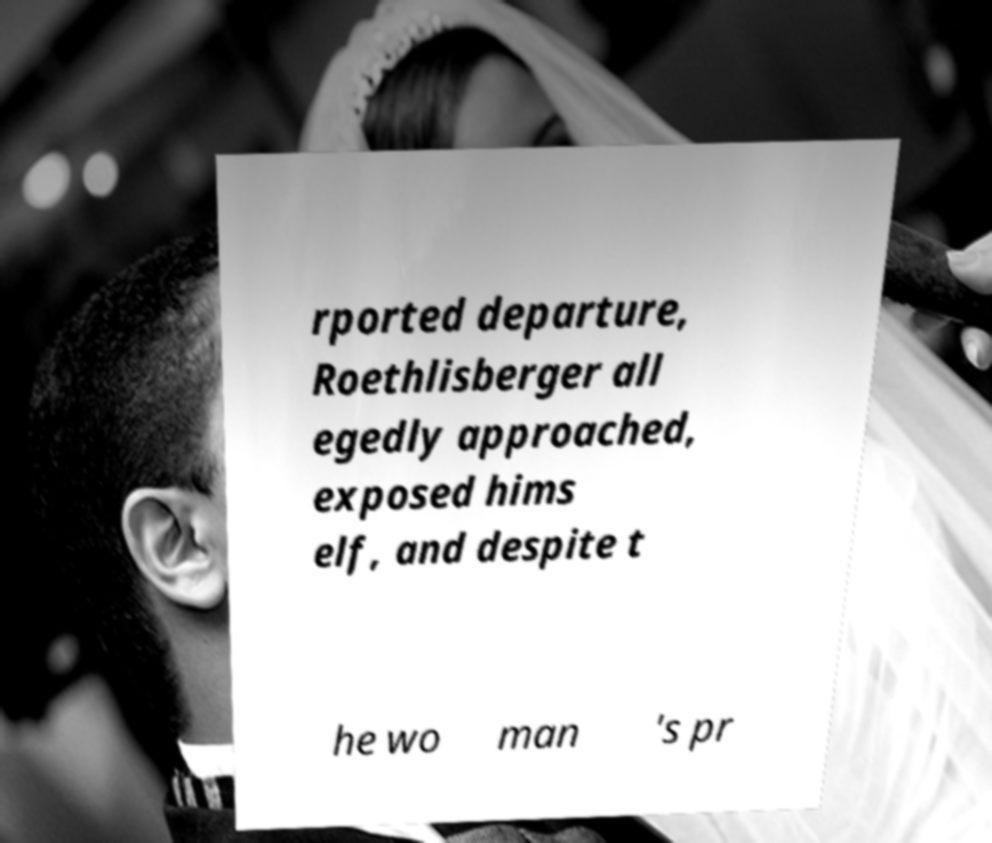I need the written content from this picture converted into text. Can you do that? rported departure, Roethlisberger all egedly approached, exposed hims elf, and despite t he wo man 's pr 